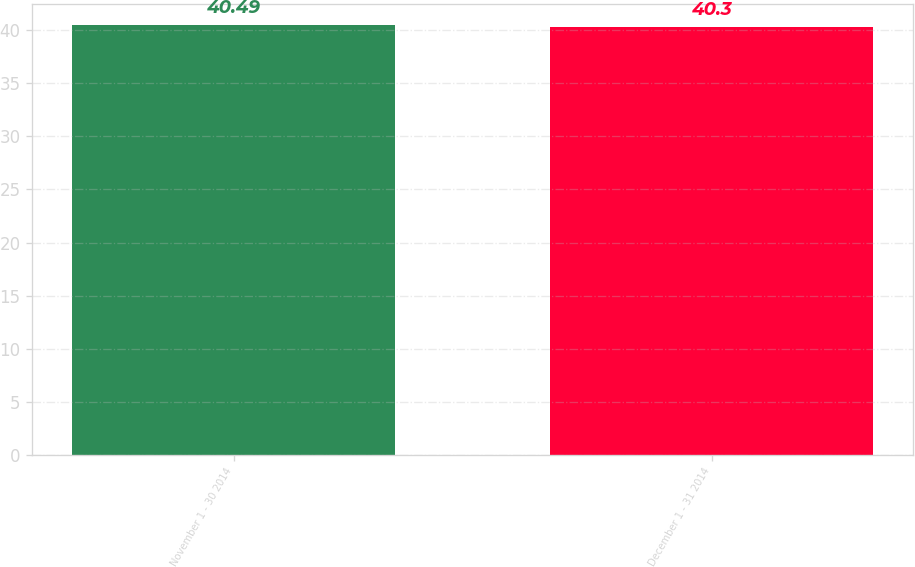<chart> <loc_0><loc_0><loc_500><loc_500><bar_chart><fcel>November 1 - 30 2014<fcel>December 1 - 31 2014<nl><fcel>40.49<fcel>40.3<nl></chart> 